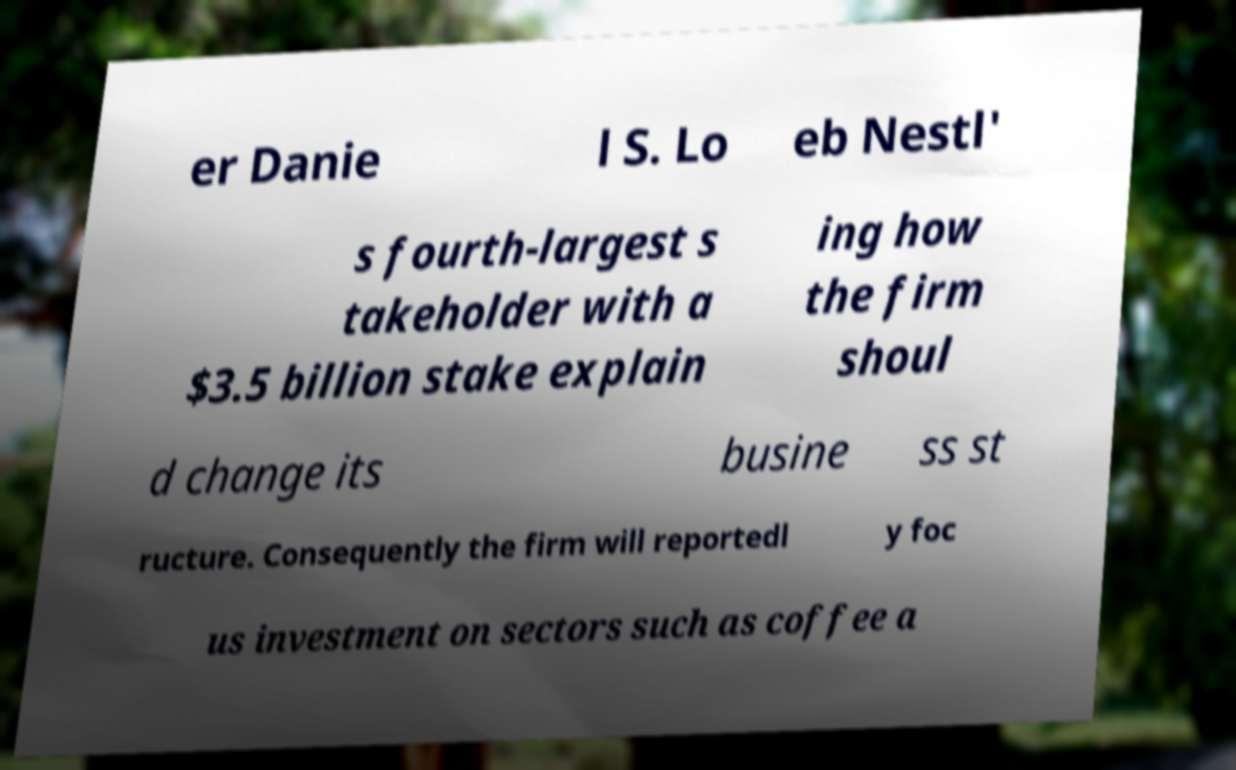Can you read and provide the text displayed in the image?This photo seems to have some interesting text. Can you extract and type it out for me? er Danie l S. Lo eb Nestl' s fourth-largest s takeholder with a $3.5 billion stake explain ing how the firm shoul d change its busine ss st ructure. Consequently the firm will reportedl y foc us investment on sectors such as coffee a 